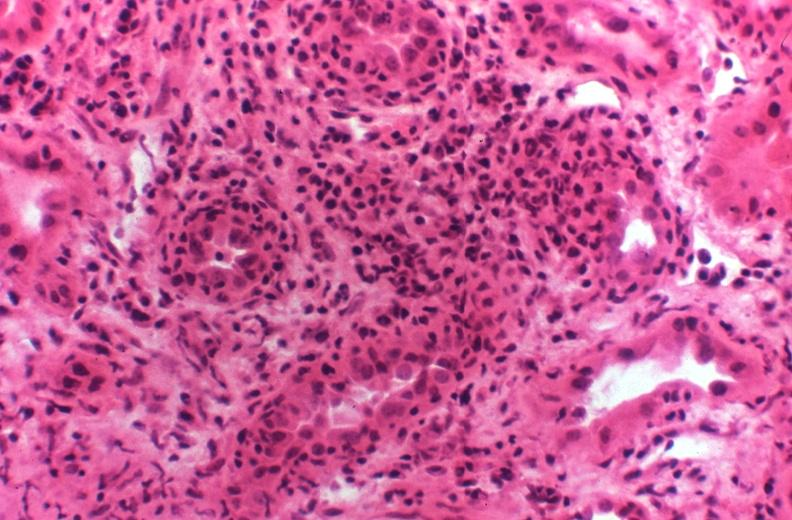where is this?
Answer the question using a single word or phrase. Urinary 